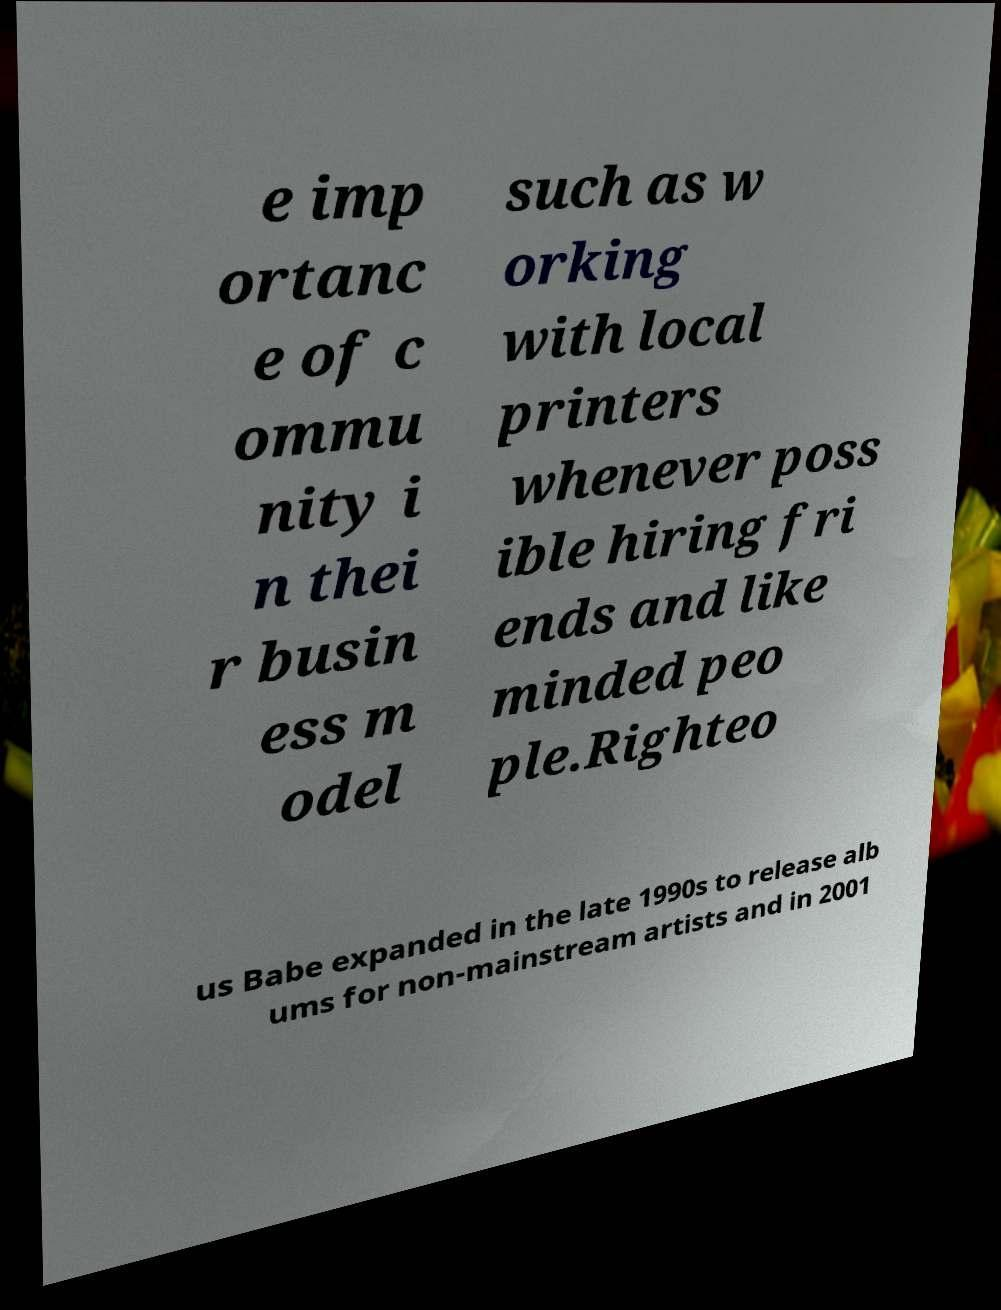For documentation purposes, I need the text within this image transcribed. Could you provide that? e imp ortanc e of c ommu nity i n thei r busin ess m odel such as w orking with local printers whenever poss ible hiring fri ends and like minded peo ple.Righteo us Babe expanded in the late 1990s to release alb ums for non-mainstream artists and in 2001 